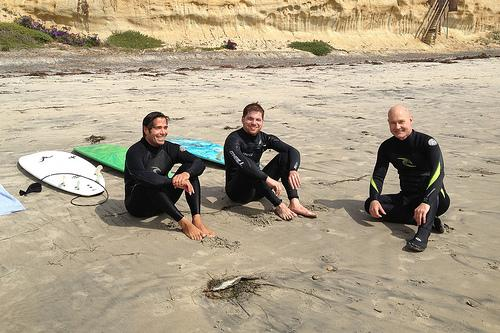Analyze the overall sentiment of the scene based on the information given. The scene appears to be relaxing and enjoyable, with people spending time by the beach and surfboards present. What color is the surfboard with the narrowest image? Blue surfboard has the narrowest image (Width: 59, Height: 59). Based on the object interactions, what activity do you think might be happening on this beach? The activity could be surfing or a casual beach day, as there are men in swimsuits and surfboards on the beach. Can you describe any details included in the wetsuit's design? The wetsuit has a yellow stripe and a decal on the shoulder. Comment on the landscape featured in the image, using information from the image. There's a tan cliff behind the beach with green plants at its base, the beach is sandy and has some rocks. Are the men's positions and attire appropriate for the location? Explain. Yes, the men are seated on the beach and wearing swim suits, which aligns with beach activities and relaxation. Count the number of men, surfboards, and plants found in the provided image. There are three men, three surfboards, and a patch of green plants. How can we describe the quality of the image, considering the height and width of the image? The image appears to be detailed with high-quality, as various objects and their features are visible and accurately captured. What items can you find lying on the beach? Surfboards in white, green, and blue, a small rock, and sand. Based on the image provided, can you identify a consistent feature among the men in the photo? All the men are wearing swim suits and are sitting on the beach. 